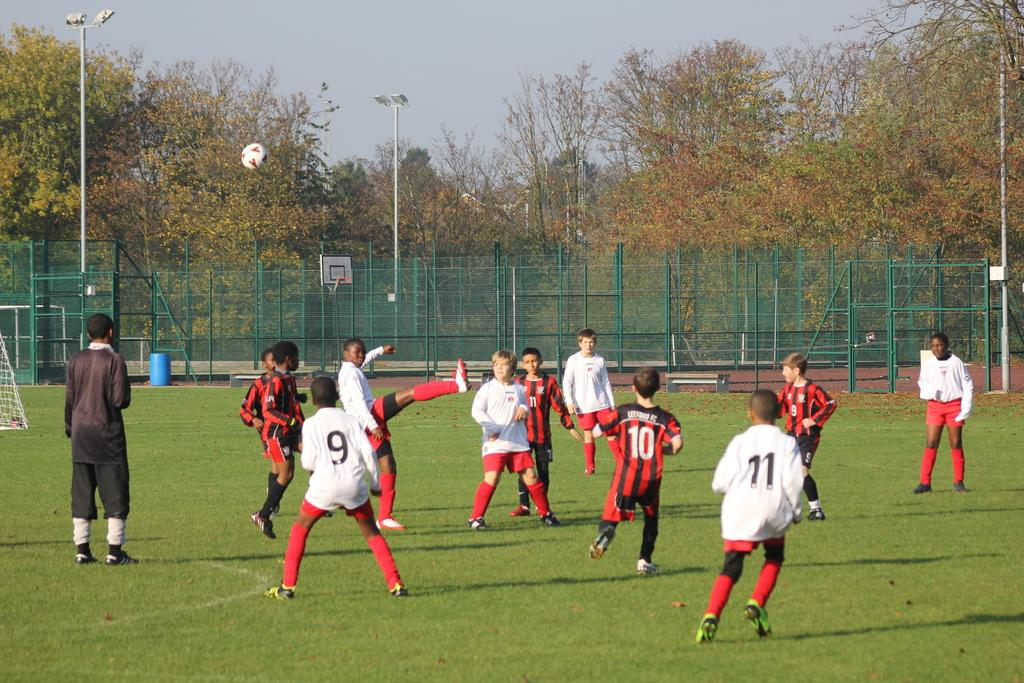<image>
Give a short and clear explanation of the subsequent image. Number 9 and 11 on the field playing soccer. 